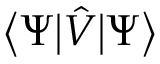Convert formula to latex. <formula><loc_0><loc_0><loc_500><loc_500>{ \left \langle } \Psi { \left | } { \hat { V } } { \right | } \Psi { \right \rangle }</formula> 